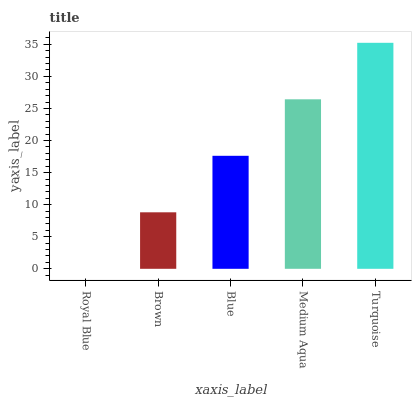Is Royal Blue the minimum?
Answer yes or no. Yes. Is Turquoise the maximum?
Answer yes or no. Yes. Is Brown the minimum?
Answer yes or no. No. Is Brown the maximum?
Answer yes or no. No. Is Brown greater than Royal Blue?
Answer yes or no. Yes. Is Royal Blue less than Brown?
Answer yes or no. Yes. Is Royal Blue greater than Brown?
Answer yes or no. No. Is Brown less than Royal Blue?
Answer yes or no. No. Is Blue the high median?
Answer yes or no. Yes. Is Blue the low median?
Answer yes or no. Yes. Is Turquoise the high median?
Answer yes or no. No. Is Brown the low median?
Answer yes or no. No. 